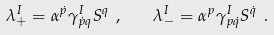<formula> <loc_0><loc_0><loc_500><loc_500>\lambda _ { + } ^ { I } = \alpha ^ { \dot { p } } \gamma ^ { I } _ { \dot { p } q } S ^ { q } \ , \quad \lambda _ { - } ^ { I } = \alpha ^ { p } \gamma ^ { I } _ { p \dot { q } } S ^ { \dot { q } } \ .</formula> 